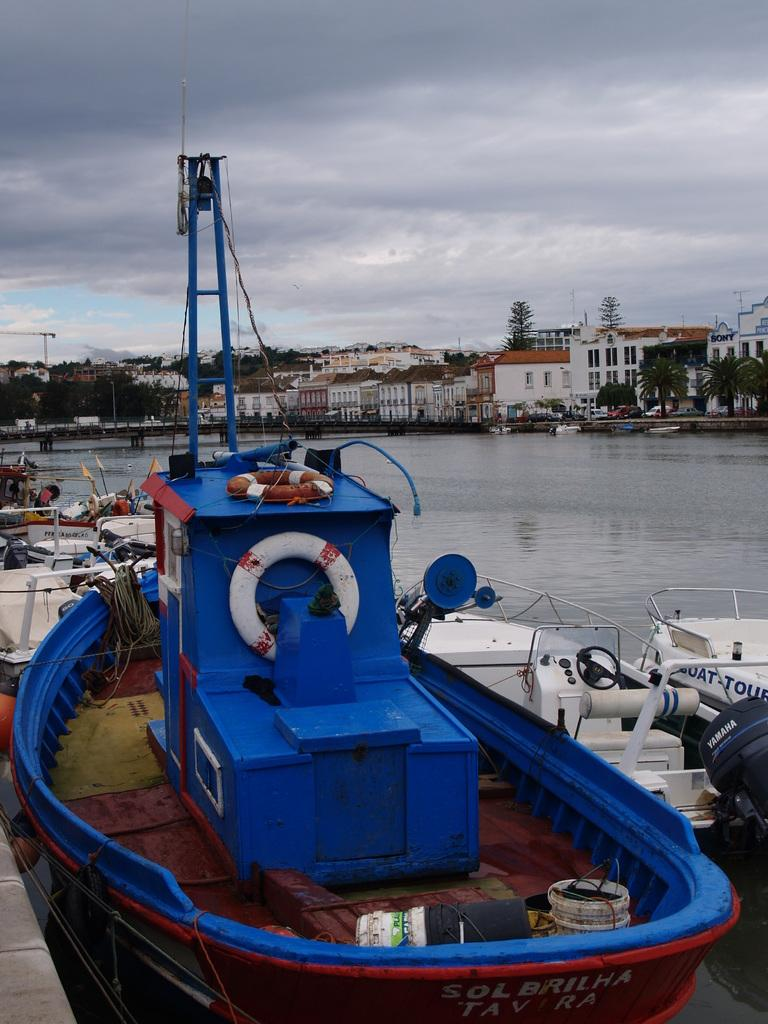What types of watercraft are present in the image? There are ships and boats in the image. What is the primary setting in which the watercraft are located? There is water visible in the image. What can be seen in the background of the image? There are buildings, trees, and the sky visible in the background of the image. What is the condition of the sky in the image? The sky is visible in the background of the image, and there are clouds in the sky. What is the profit margin of the tub in the image? There is no tub present in the image, so it is not possible to determine its profit margin. 